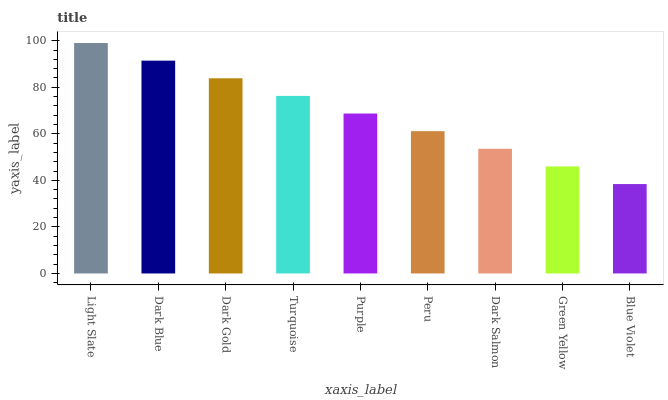Is Blue Violet the minimum?
Answer yes or no. Yes. Is Light Slate the maximum?
Answer yes or no. Yes. Is Dark Blue the minimum?
Answer yes or no. No. Is Dark Blue the maximum?
Answer yes or no. No. Is Light Slate greater than Dark Blue?
Answer yes or no. Yes. Is Dark Blue less than Light Slate?
Answer yes or no. Yes. Is Dark Blue greater than Light Slate?
Answer yes or no. No. Is Light Slate less than Dark Blue?
Answer yes or no. No. Is Purple the high median?
Answer yes or no. Yes. Is Purple the low median?
Answer yes or no. Yes. Is Dark Gold the high median?
Answer yes or no. No. Is Dark Blue the low median?
Answer yes or no. No. 